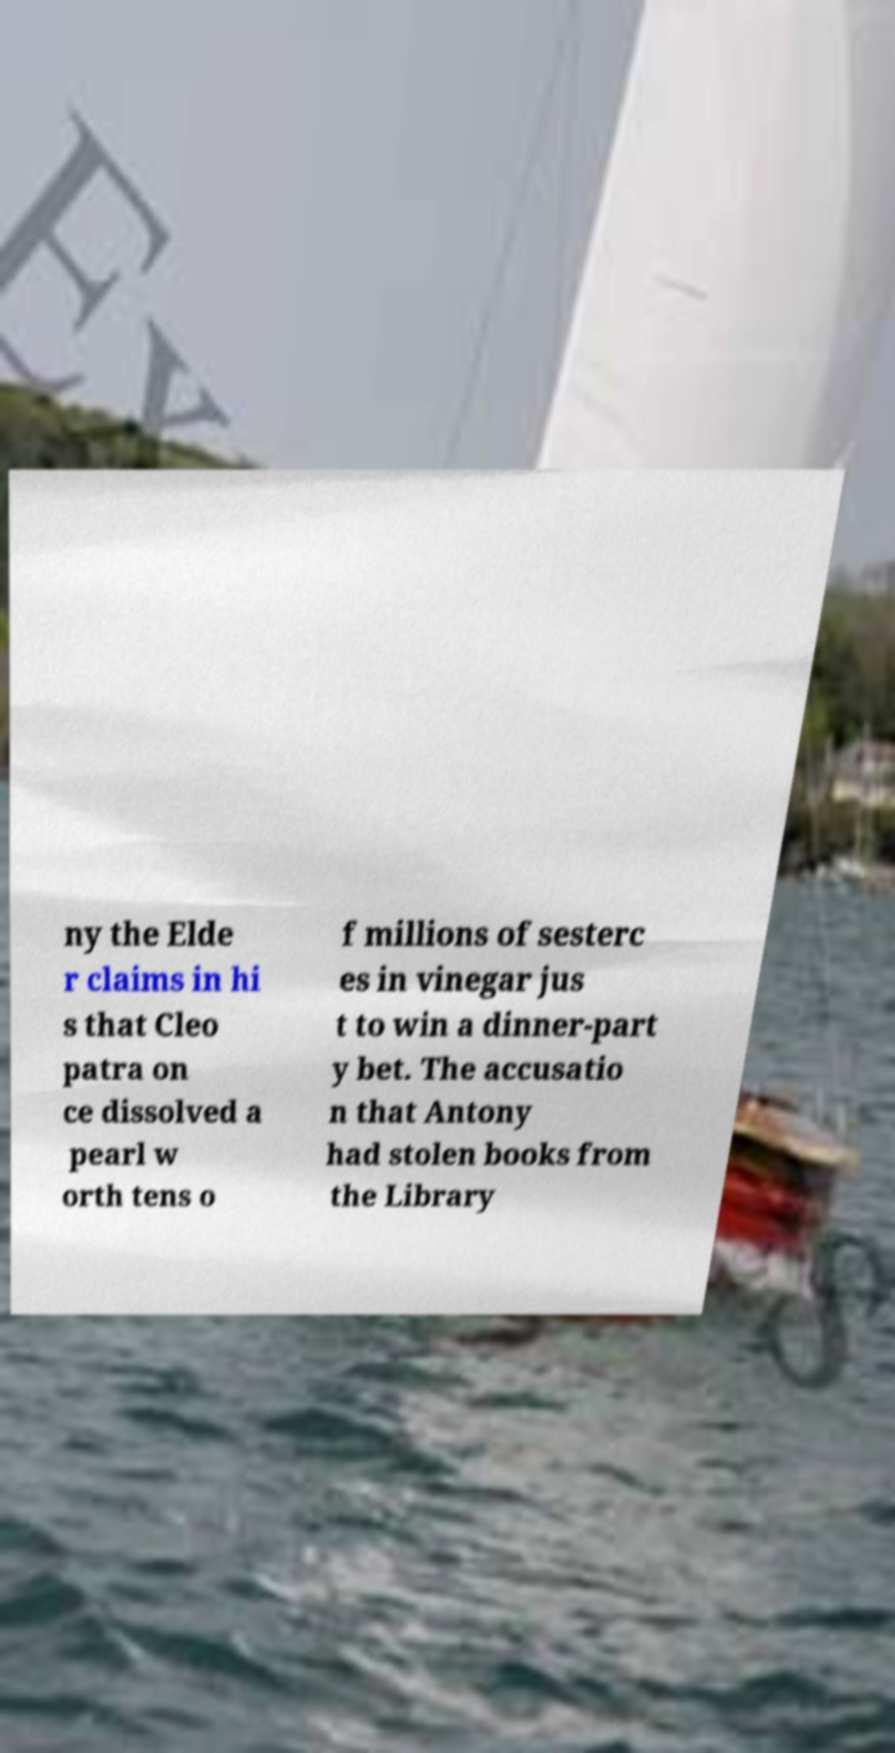Can you read and provide the text displayed in the image?This photo seems to have some interesting text. Can you extract and type it out for me? ny the Elde r claims in hi s that Cleo patra on ce dissolved a pearl w orth tens o f millions of sesterc es in vinegar jus t to win a dinner-part y bet. The accusatio n that Antony had stolen books from the Library 